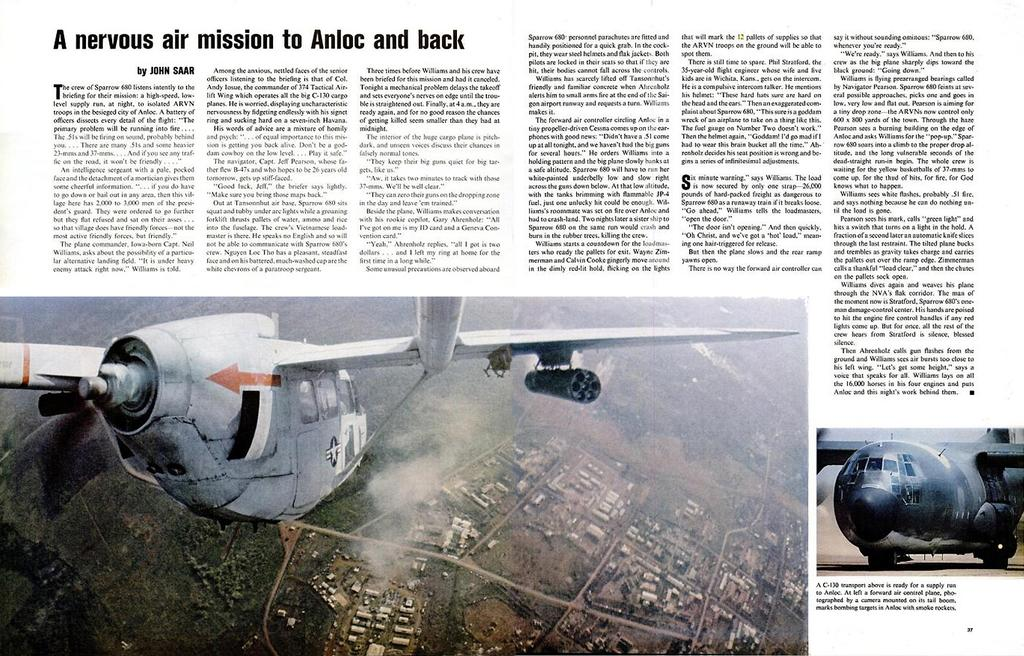What is the main subject of the image? The main subject of the image is a photo of a newspaper. What else can be seen in the image besides the newspaper? There are aircrafts visible in the image. Can you read any text in the image? Yes, there is text visible in the image. What type of support can be seen holding up the aircraft in the image? There is no support visible in the image holding up the aircraft; it appears to be a photo of aircrafts in the sky. 